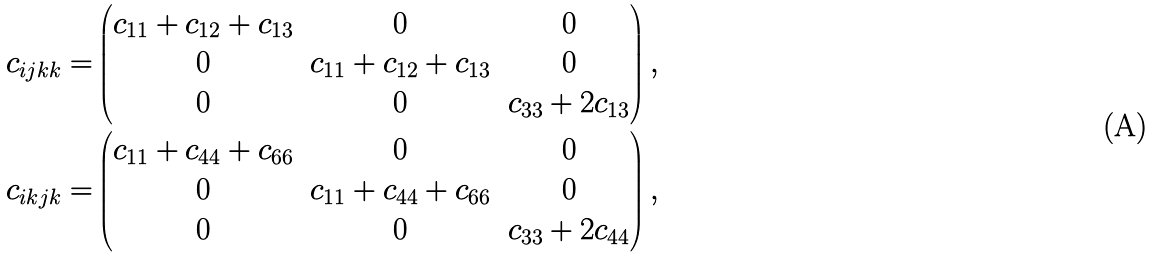<formula> <loc_0><loc_0><loc_500><loc_500>c _ { i j k k } = & \begin{pmatrix} c _ { 1 1 } + c _ { 1 2 } + c _ { 1 3 } & 0 & 0 \\ 0 & c _ { 1 1 } + c _ { 1 2 } + c _ { 1 3 } & 0 \\ 0 & 0 & c _ { 3 3 } + 2 c _ { 1 3 } \end{pmatrix} , \\ c _ { i k j k } = & \begin{pmatrix} c _ { 1 1 } + c _ { 4 4 } + c _ { 6 6 } & 0 & 0 \\ 0 & c _ { 1 1 } + c _ { 4 4 } + c _ { 6 6 } & 0 \\ 0 & 0 & c _ { 3 3 } + 2 c _ { 4 4 } \end{pmatrix} ,</formula> 